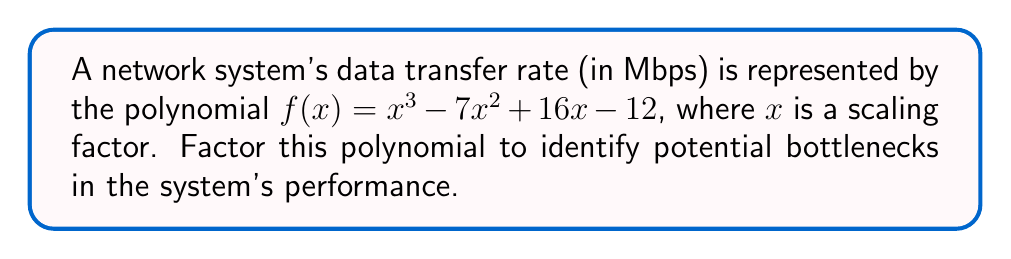Can you solve this math problem? To factor this polynomial, we'll follow these steps:

1) First, let's check if there's a common factor. In this case, there isn't.

2) Next, we'll try to guess one of the factors. Since the constant term is -12, possible factors are ±1, ±2, ±3, ±4, ±6, ±12.

3) Using the rational root theorem, we can test these values. We find that $f(1) = 0$, so $(x-1)$ is a factor.

4) Divide $f(x)$ by $(x-1)$ using polynomial long division:

   $$x^3 - 7x^2 + 16x - 12 = (x-1)(x^2 - 6x + 12)$$

5) Now we need to factor $x^2 - 6x + 12$. This is a quadratic expression.

6) For a quadratic $ax^2 + bx + c$, we're looking for two numbers that multiply to give $ac$ and add to give $b$.

7) In this case, we need two numbers that multiply to give 12 and add to give -6. These numbers are -2 and -4.

8) Therefore, $x^2 - 6x + 12 = (x-2)(x-4)$

9) Putting it all together:

   $$f(x) = x^3 - 7x^2 + 16x - 12 = (x-1)(x-2)(x-4)$$

This factorization reveals that the system's performance might experience bottlenecks at scaling factors of 1, 2, and 4.
Answer: $(x-1)(x-2)(x-4)$ 